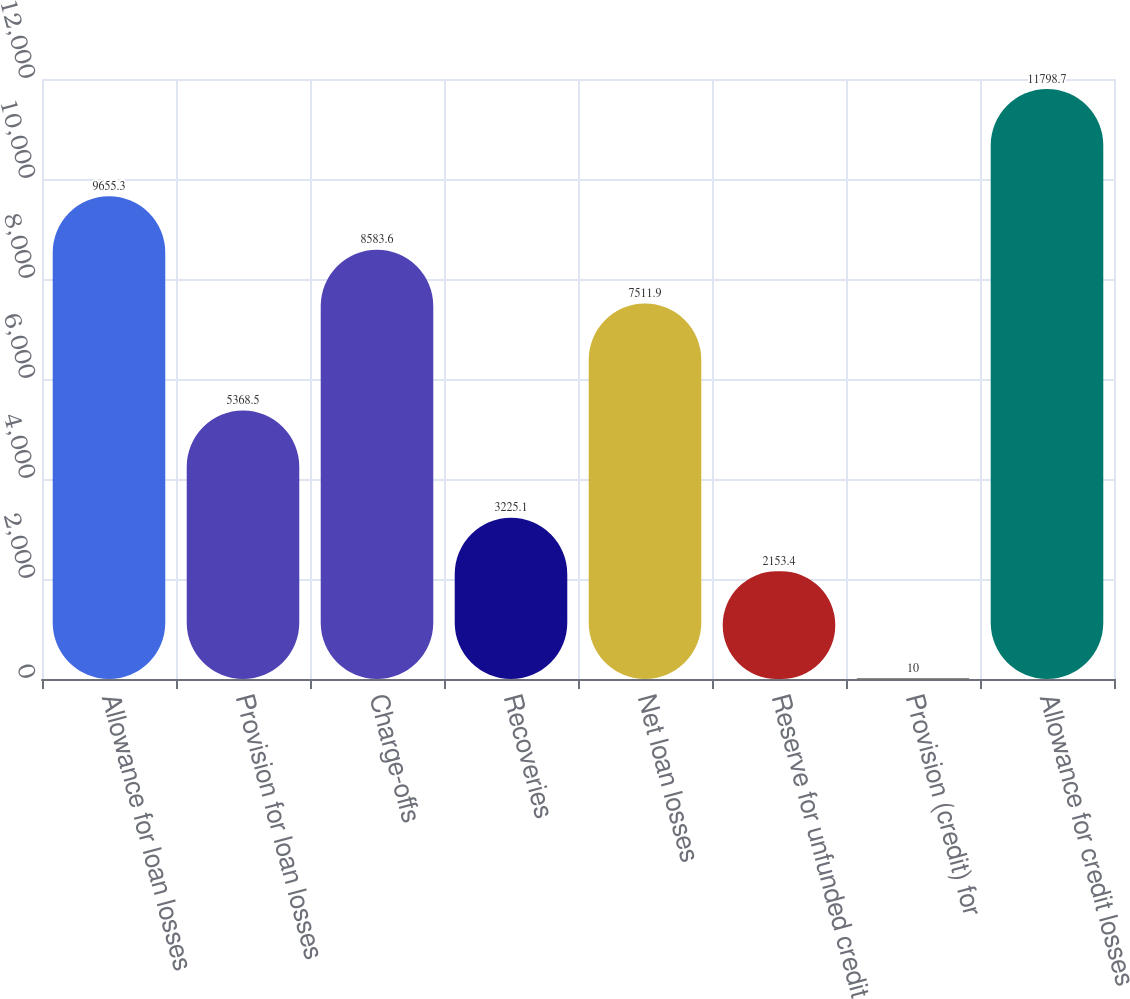Convert chart to OTSL. <chart><loc_0><loc_0><loc_500><loc_500><bar_chart><fcel>Allowance for loan losses<fcel>Provision for loan losses<fcel>Charge-offs<fcel>Recoveries<fcel>Net loan losses<fcel>Reserve for unfunded credit<fcel>Provision (credit) for<fcel>Allowance for credit losses<nl><fcel>9655.3<fcel>5368.5<fcel>8583.6<fcel>3225.1<fcel>7511.9<fcel>2153.4<fcel>10<fcel>11798.7<nl></chart> 